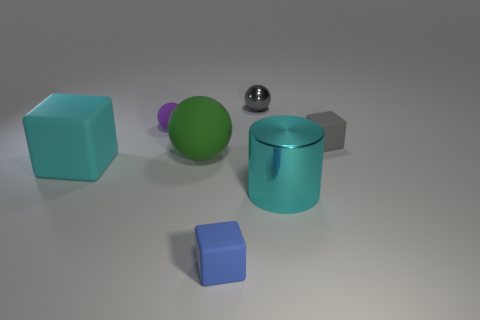Add 3 purple balls. How many objects exist? 10 Subtract all cylinders. How many objects are left? 6 Subtract 0 blue balls. How many objects are left? 7 Subtract all yellow matte objects. Subtract all tiny blue matte things. How many objects are left? 6 Add 1 big cyan things. How many big cyan things are left? 3 Add 5 small purple things. How many small purple things exist? 6 